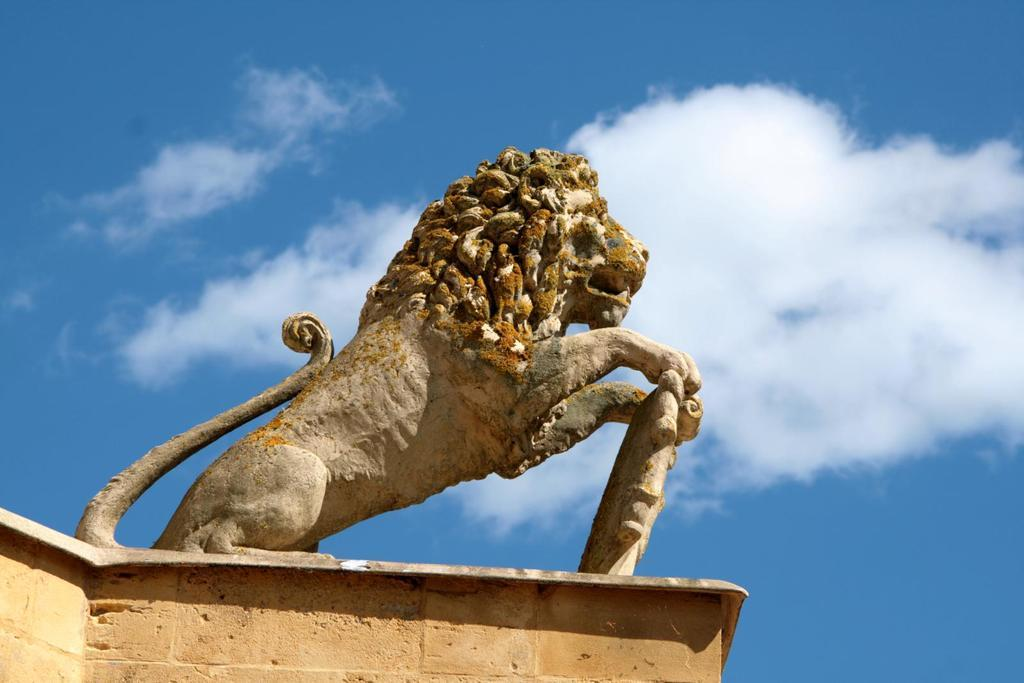What is the main subject of the image? There is a statue of a lion in the image. Can you describe the statue in more detail? The statue is of a lion, which is a large, powerful animal. What is the lion statue made of? The facts provided do not specify the material of the statue, so we cannot determine that from the image. Where is the drain located in the image? There is no drain present in the image; it only features a statue of a lion. What type of umbrella is being used by the lion in the image? There is no umbrella present in the image, as it only features a statue of a lion. 